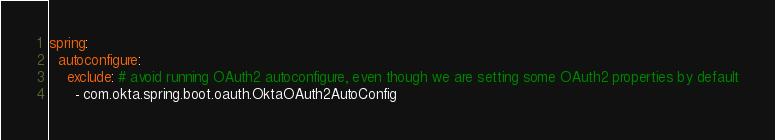Convert code to text. <code><loc_0><loc_0><loc_500><loc_500><_YAML_>spring:
  autoconfigure:
    exclude: # avoid running OAuth2 autoconfigure, even though we are setting some OAuth2 properties by default
      - com.okta.spring.boot.oauth.OktaOAuth2AutoConfig</code> 